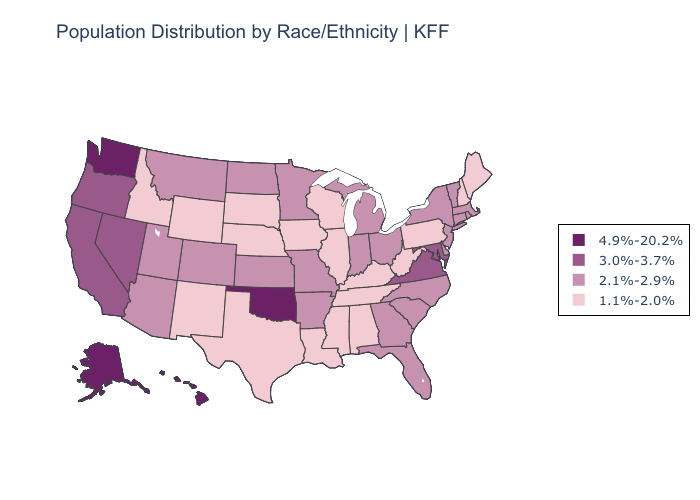Among the states that border California , which have the lowest value?
Concise answer only. Arizona. What is the value of Maine?
Short answer required. 1.1%-2.0%. Does Maine have the highest value in the Northeast?
Write a very short answer. No. What is the highest value in the West ?
Be succinct. 4.9%-20.2%. What is the value of Illinois?
Give a very brief answer. 1.1%-2.0%. Does New Jersey have the highest value in the USA?
Concise answer only. No. What is the value of Arkansas?
Give a very brief answer. 2.1%-2.9%. What is the lowest value in states that border Montana?
Write a very short answer. 1.1%-2.0%. Name the states that have a value in the range 4.9%-20.2%?
Give a very brief answer. Alaska, Hawaii, Oklahoma, Washington. Among the states that border Maryland , which have the lowest value?
Keep it brief. Pennsylvania, West Virginia. What is the value of New Mexico?
Answer briefly. 1.1%-2.0%. What is the highest value in the USA?
Concise answer only. 4.9%-20.2%. Does Utah have the highest value in the West?
Answer briefly. No. Name the states that have a value in the range 3.0%-3.7%?
Answer briefly. California, Maryland, Nevada, Oregon, Virginia. What is the value of North Carolina?
Short answer required. 2.1%-2.9%. 